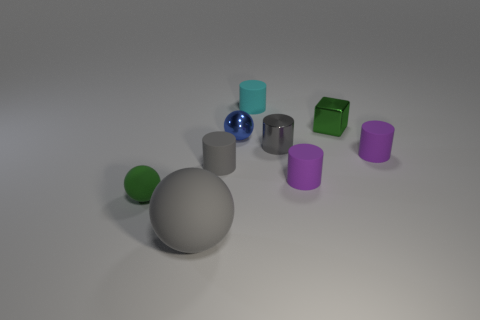What is the shape of the tiny rubber object that is both to the left of the green metallic object and right of the tiny metal cylinder?
Offer a terse response. Cylinder. Is the number of small gray cylinders behind the tiny gray metal thing the same as the number of big cylinders?
Provide a short and direct response. Yes. What number of objects are tiny spheres or gray things that are behind the large matte sphere?
Your response must be concise. 4. Is there another object of the same shape as the tiny blue shiny thing?
Your answer should be very brief. Yes. Are there the same number of purple cylinders that are behind the tiny gray rubber cylinder and big gray rubber objects that are in front of the small blue shiny sphere?
Provide a succinct answer. Yes. Is there any other thing that has the same size as the gray ball?
Your answer should be very brief. No. What number of purple objects are tiny matte cylinders or blocks?
Ensure brevity in your answer.  2. How many gray metallic objects are the same size as the block?
Your response must be concise. 1. There is a tiny object that is left of the tiny blue shiny ball and to the right of the large gray thing; what color is it?
Your response must be concise. Gray. Are there more gray metal cylinders that are behind the tiny green sphere than large cyan metal cylinders?
Offer a terse response. Yes. 